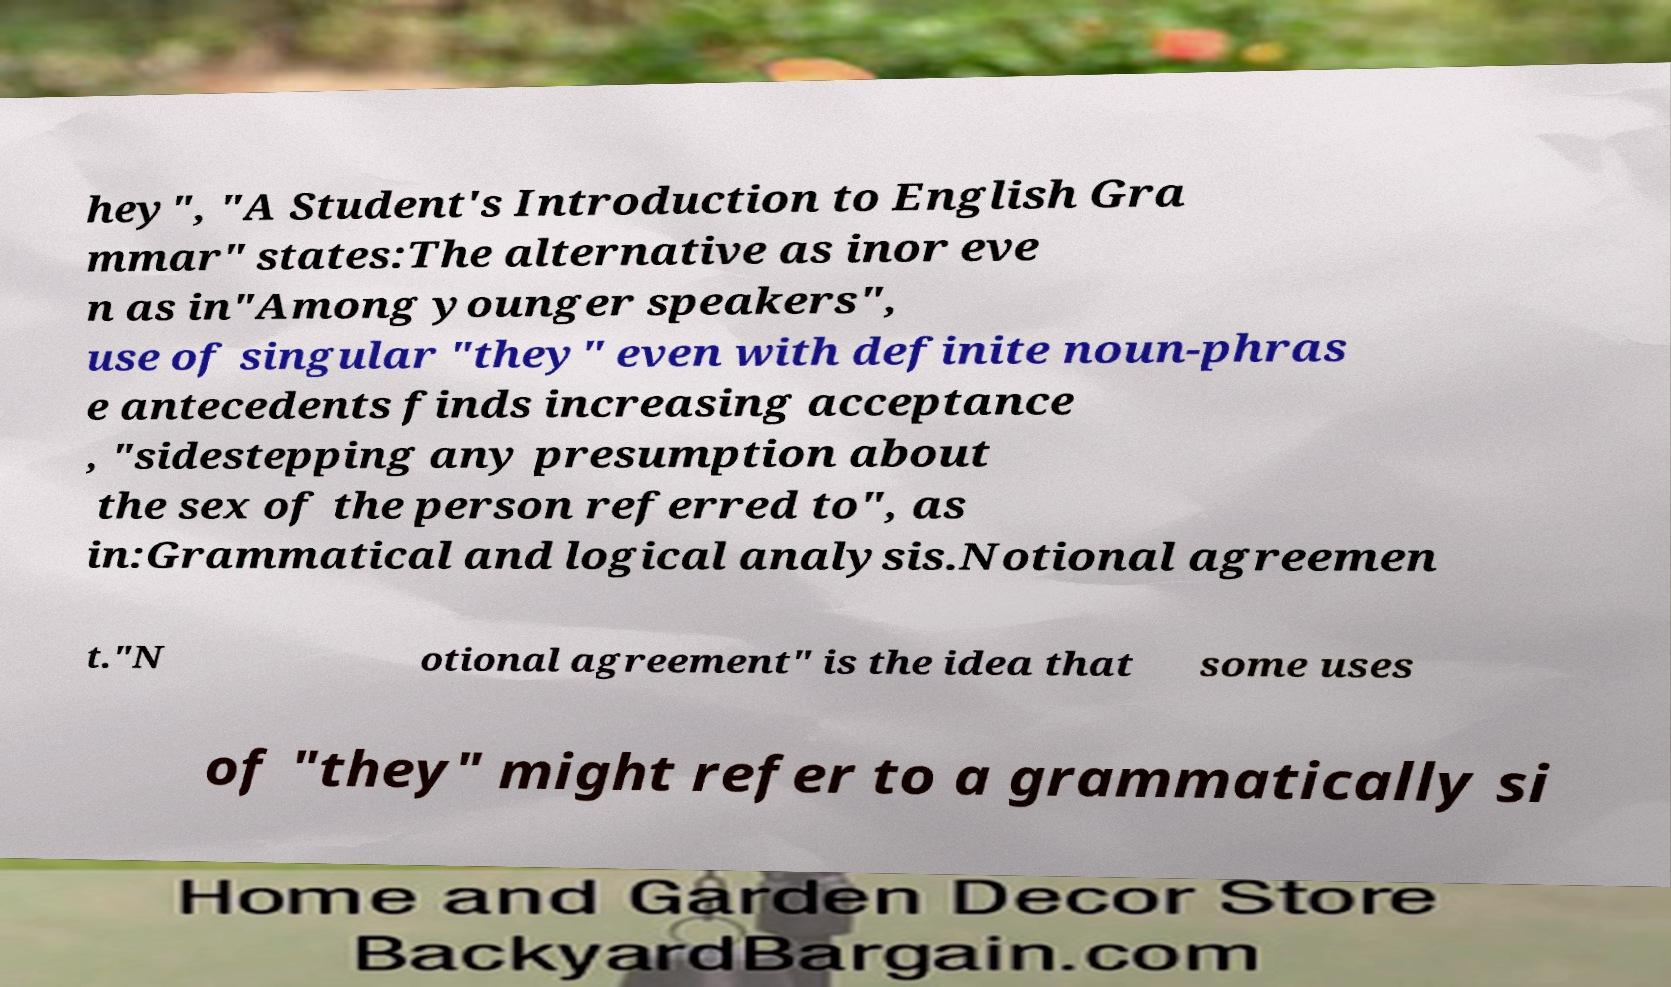Please identify and transcribe the text found in this image. hey", "A Student's Introduction to English Gra mmar" states:The alternative as inor eve n as in"Among younger speakers", use of singular "they" even with definite noun-phras e antecedents finds increasing acceptance , "sidestepping any presumption about the sex of the person referred to", as in:Grammatical and logical analysis.Notional agreemen t."N otional agreement" is the idea that some uses of "they" might refer to a grammatically si 